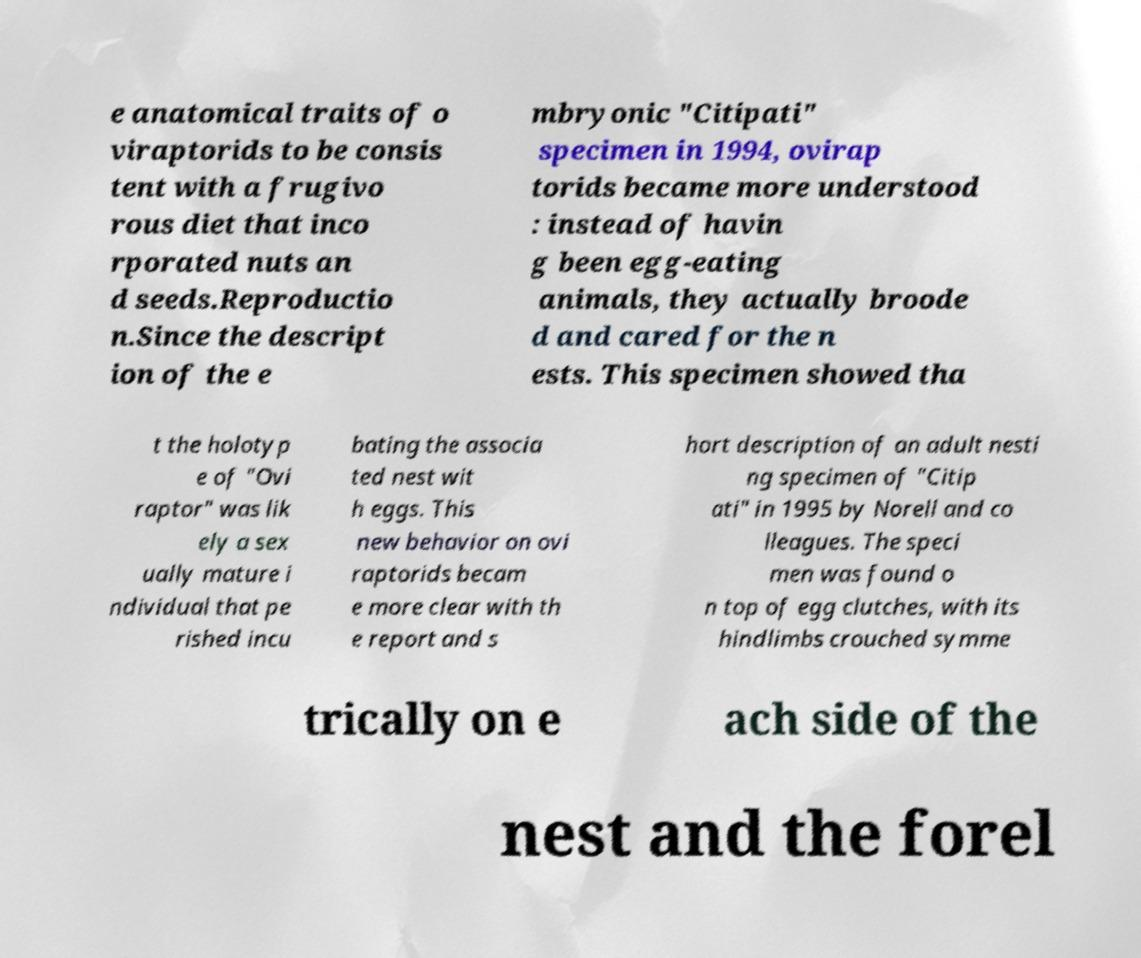Could you extract and type out the text from this image? e anatomical traits of o viraptorids to be consis tent with a frugivo rous diet that inco rporated nuts an d seeds.Reproductio n.Since the descript ion of the e mbryonic "Citipati" specimen in 1994, ovirap torids became more understood : instead of havin g been egg-eating animals, they actually broode d and cared for the n ests. This specimen showed tha t the holotyp e of "Ovi raptor" was lik ely a sex ually mature i ndividual that pe rished incu bating the associa ted nest wit h eggs. This new behavior on ovi raptorids becam e more clear with th e report and s hort description of an adult nesti ng specimen of "Citip ati" in 1995 by Norell and co lleagues. The speci men was found o n top of egg clutches, with its hindlimbs crouched symme trically on e ach side of the nest and the forel 